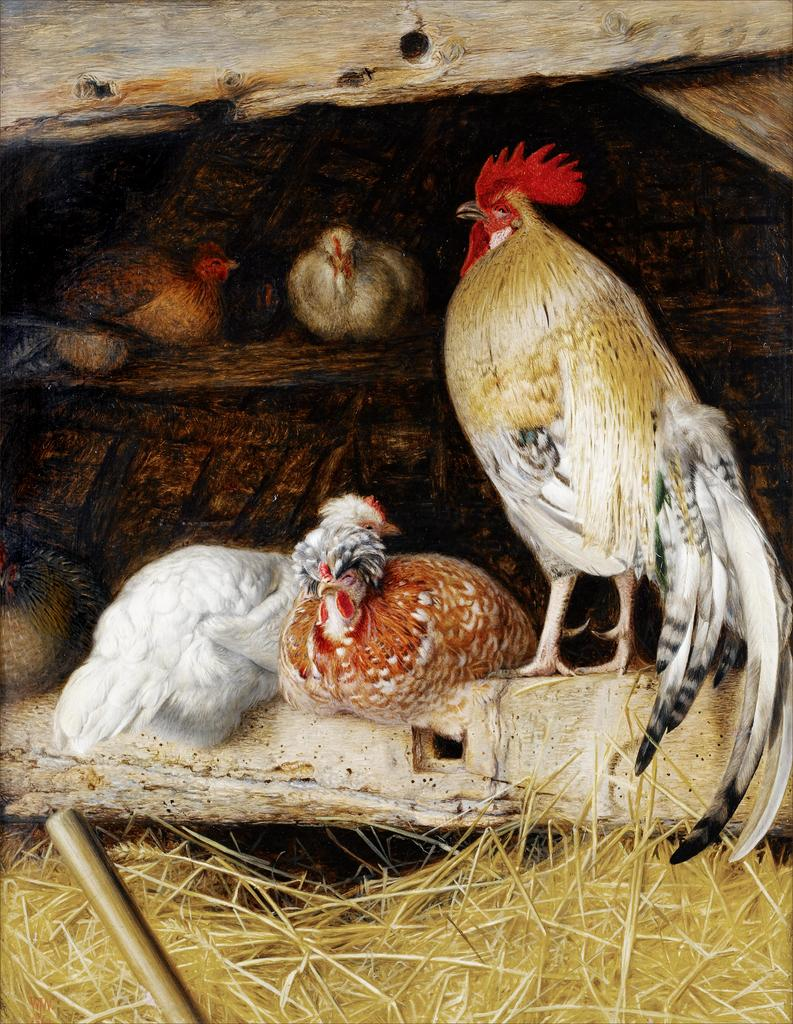What animals are in the center of the image? There are hens in the center of the image. What type of structures can be seen on the top and bottom sides of the image? There are wooden poles at the top and bottom sides of the image. What type of vegetation is present at the bottom side of the image? There is dry grass at the bottom side of the image. How is the image created? The image appears to be a painting. What type of ear is visible on the hens in the image? Hens do not have ears like humans, so there are no visible ears on the hens in the image. 